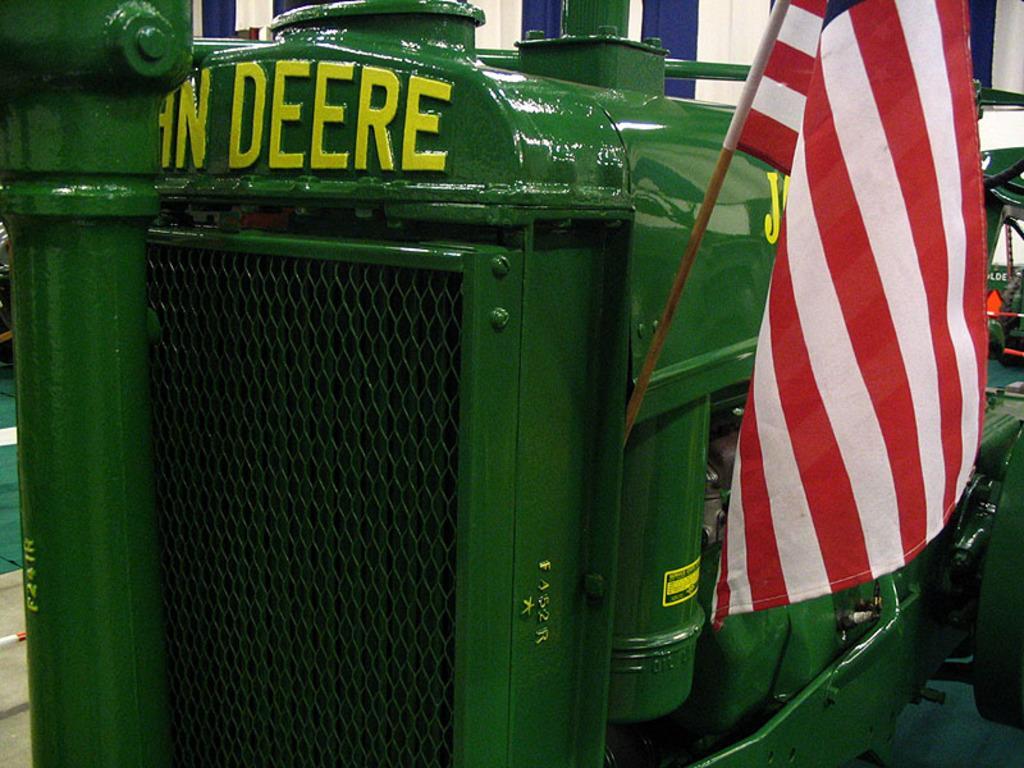Can you describe this image briefly? This image consists of a vehicle in green color. To which, there is a flag fixed. It looks like it is kept in a hall. In the background, we can see a cloth in blue and white color. 